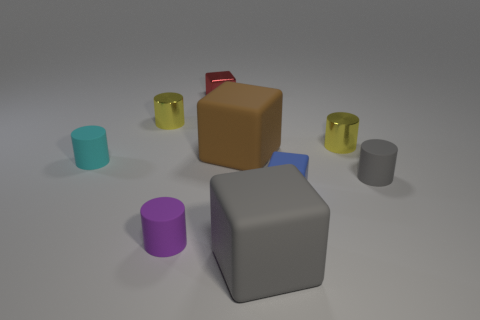The small matte cylinder behind the tiny matte thing that is right of the yellow metallic cylinder right of the big brown object is what color?
Make the answer very short. Cyan. There is a gray object that is on the right side of the gray block; what size is it?
Your response must be concise. Small. What number of tiny things are purple matte things or purple matte cubes?
Ensure brevity in your answer.  1. What color is the cylinder that is behind the brown rubber object and on the left side of the big brown rubber block?
Ensure brevity in your answer.  Yellow. Is there a large cyan metallic object of the same shape as the big brown object?
Your response must be concise. No. What is the blue block made of?
Offer a terse response. Rubber. There is a small purple rubber object; are there any purple cylinders to the left of it?
Offer a terse response. No. Does the red object have the same shape as the small blue thing?
Your response must be concise. Yes. How many other things are the same size as the brown matte block?
Provide a short and direct response. 1. What number of objects are either yellow cylinders that are left of the purple rubber thing or small purple objects?
Provide a short and direct response. 2. 